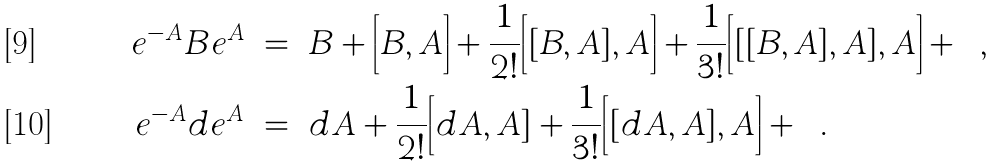<formula> <loc_0><loc_0><loc_500><loc_500>e ^ { - A } B e ^ { A } \ & = \ B + \Big [ B , A \Big ] + \frac { 1 } { 2 ! } \Big [ [ B , A ] , A \Big ] + \frac { 1 } { 3 ! } \Big [ [ [ B , A ] , A ] , A \Big ] + \cdots \, , \\ e ^ { - A } d e ^ { A } \ & = \ d A + \frac { 1 } { 2 ! } \Big [ d A , A ] + \frac { 1 } { 3 ! } \Big [ [ d A , A ] , A \Big ] + \cdots \, .</formula> 